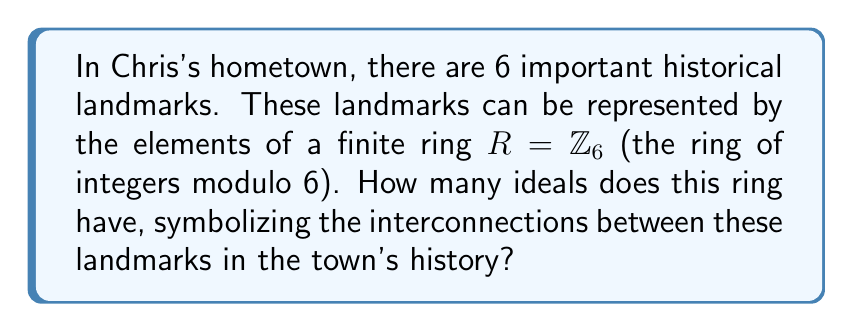Could you help me with this problem? To find the number of ideals in the ring $R = \mathbb{Z}_6$, we follow these steps:

1) First, recall that the ideals of $\mathbb{Z}_n$ are precisely the subgroups of the additive group of $\mathbb{Z}_n$.

2) The subgroups of $\mathbb{Z}_n$ are of the form $\langle d \rangle$ where $d$ divides $n$.

3) The divisors of 6 are 1, 2, 3, and 6.

4) Let's examine each divisor:
   
   a) $\langle 1 \rangle = \{0, 1, 2, 3, 4, 5\} = \mathbb{Z}_6$
   b) $\langle 2 \rangle = \{0, 2, 4\}$
   c) $\langle 3 \rangle = \{0, 3\}$
   d) $\langle 6 \rangle = \{0\}$

5) Each of these generates a distinct ideal in $\mathbb{Z}_6$.

6) Therefore, the number of ideals in $\mathbb{Z}_6$ is equal to the number of divisors of 6, which is 4.

Historically, this could represent how the landmarks are interconnected in groups: all landmarks together, pairs of landmarks, trios of landmarks, and each landmark individually.
Answer: 4 